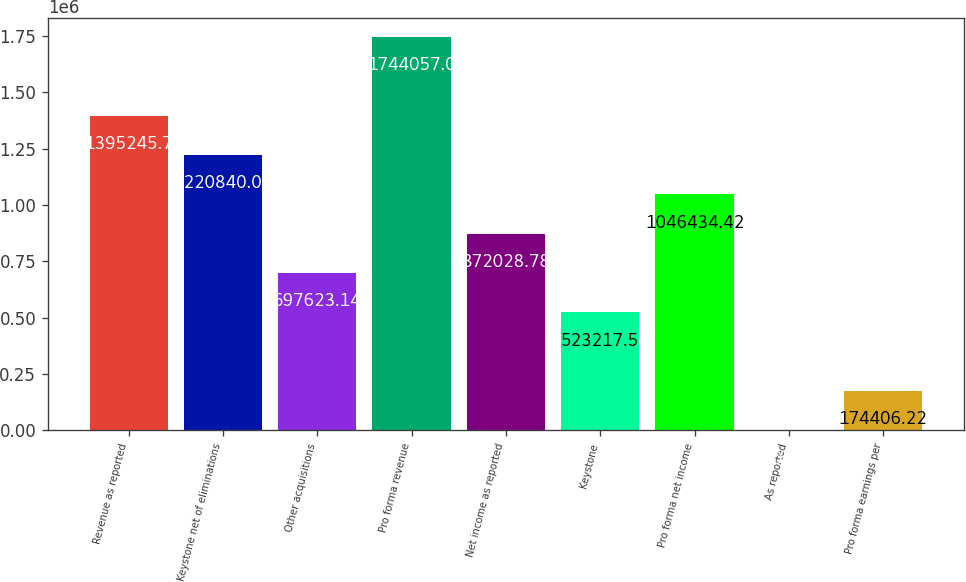Convert chart to OTSL. <chart><loc_0><loc_0><loc_500><loc_500><bar_chart><fcel>Revenue as reported<fcel>Keystone net of eliminations<fcel>Other acquisitions<fcel>Pro forma revenue<fcel>Net income as reported<fcel>Keystone<fcel>Pro forma net income<fcel>As reported<fcel>Pro forma earnings per<nl><fcel>1.39525e+06<fcel>1.22084e+06<fcel>697623<fcel>1.74406e+06<fcel>872029<fcel>523218<fcel>1.04643e+06<fcel>0.58<fcel>174406<nl></chart> 